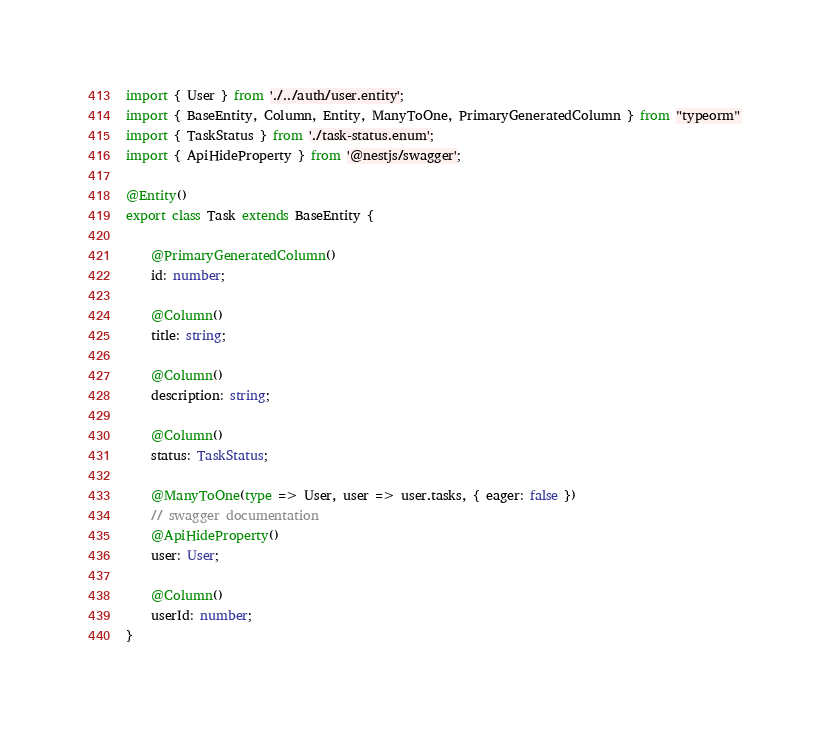<code> <loc_0><loc_0><loc_500><loc_500><_TypeScript_>import { User } from './../auth/user.entity';
import { BaseEntity, Column, Entity, ManyToOne, PrimaryGeneratedColumn } from "typeorm"
import { TaskStatus } from './task-status.enum';
import { ApiHideProperty } from '@nestjs/swagger';

@Entity()
export class Task extends BaseEntity {

    @PrimaryGeneratedColumn()
    id: number;

    @Column()
    title: string;

    @Column()
    description: string;

    @Column()
    status: TaskStatus;

    @ManyToOne(type => User, user => user.tasks, { eager: false })
    // swagger documentation
    @ApiHideProperty()
    user: User;
    
    @Column()
    userId: number;
}</code> 